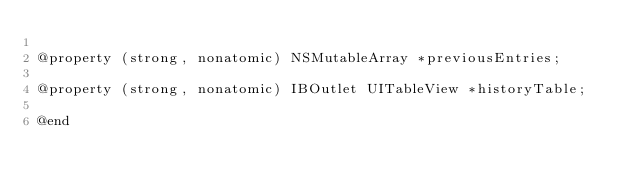Convert code to text. <code><loc_0><loc_0><loc_500><loc_500><_C_>
@property (strong, nonatomic) NSMutableArray *previousEntries;

@property (strong, nonatomic) IBOutlet UITableView *historyTable;

@end
</code> 